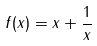<formula> <loc_0><loc_0><loc_500><loc_500>f ( x ) = x + \frac { 1 } { x }</formula> 